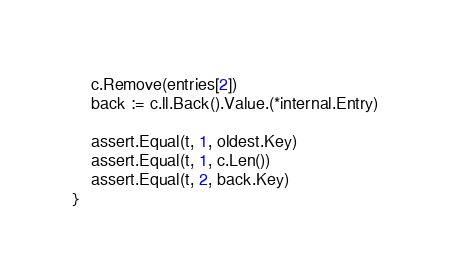Convert code to text. <code><loc_0><loc_0><loc_500><loc_500><_Go_>	c.Remove(entries[2])
	back := c.ll.Back().Value.(*internal.Entry)

	assert.Equal(t, 1, oldest.Key)
	assert.Equal(t, 1, c.Len())
	assert.Equal(t, 2, back.Key)
}
</code> 